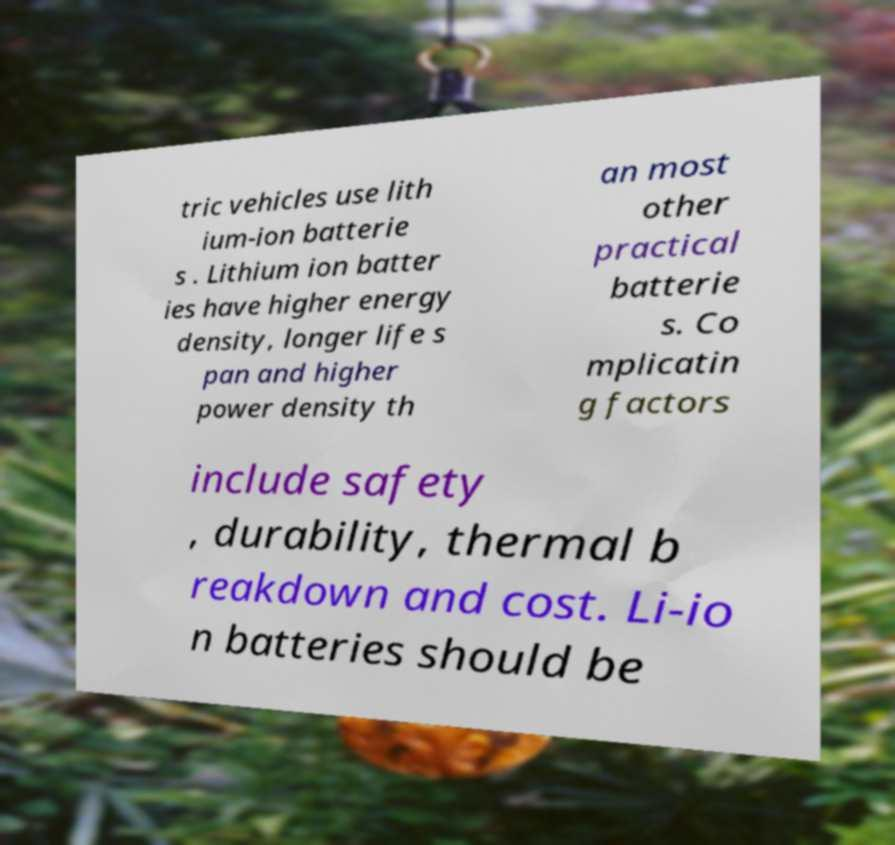Please read and relay the text visible in this image. What does it say? tric vehicles use lith ium-ion batterie s . Lithium ion batter ies have higher energy density, longer life s pan and higher power density th an most other practical batterie s. Co mplicatin g factors include safety , durability, thermal b reakdown and cost. Li-io n batteries should be 